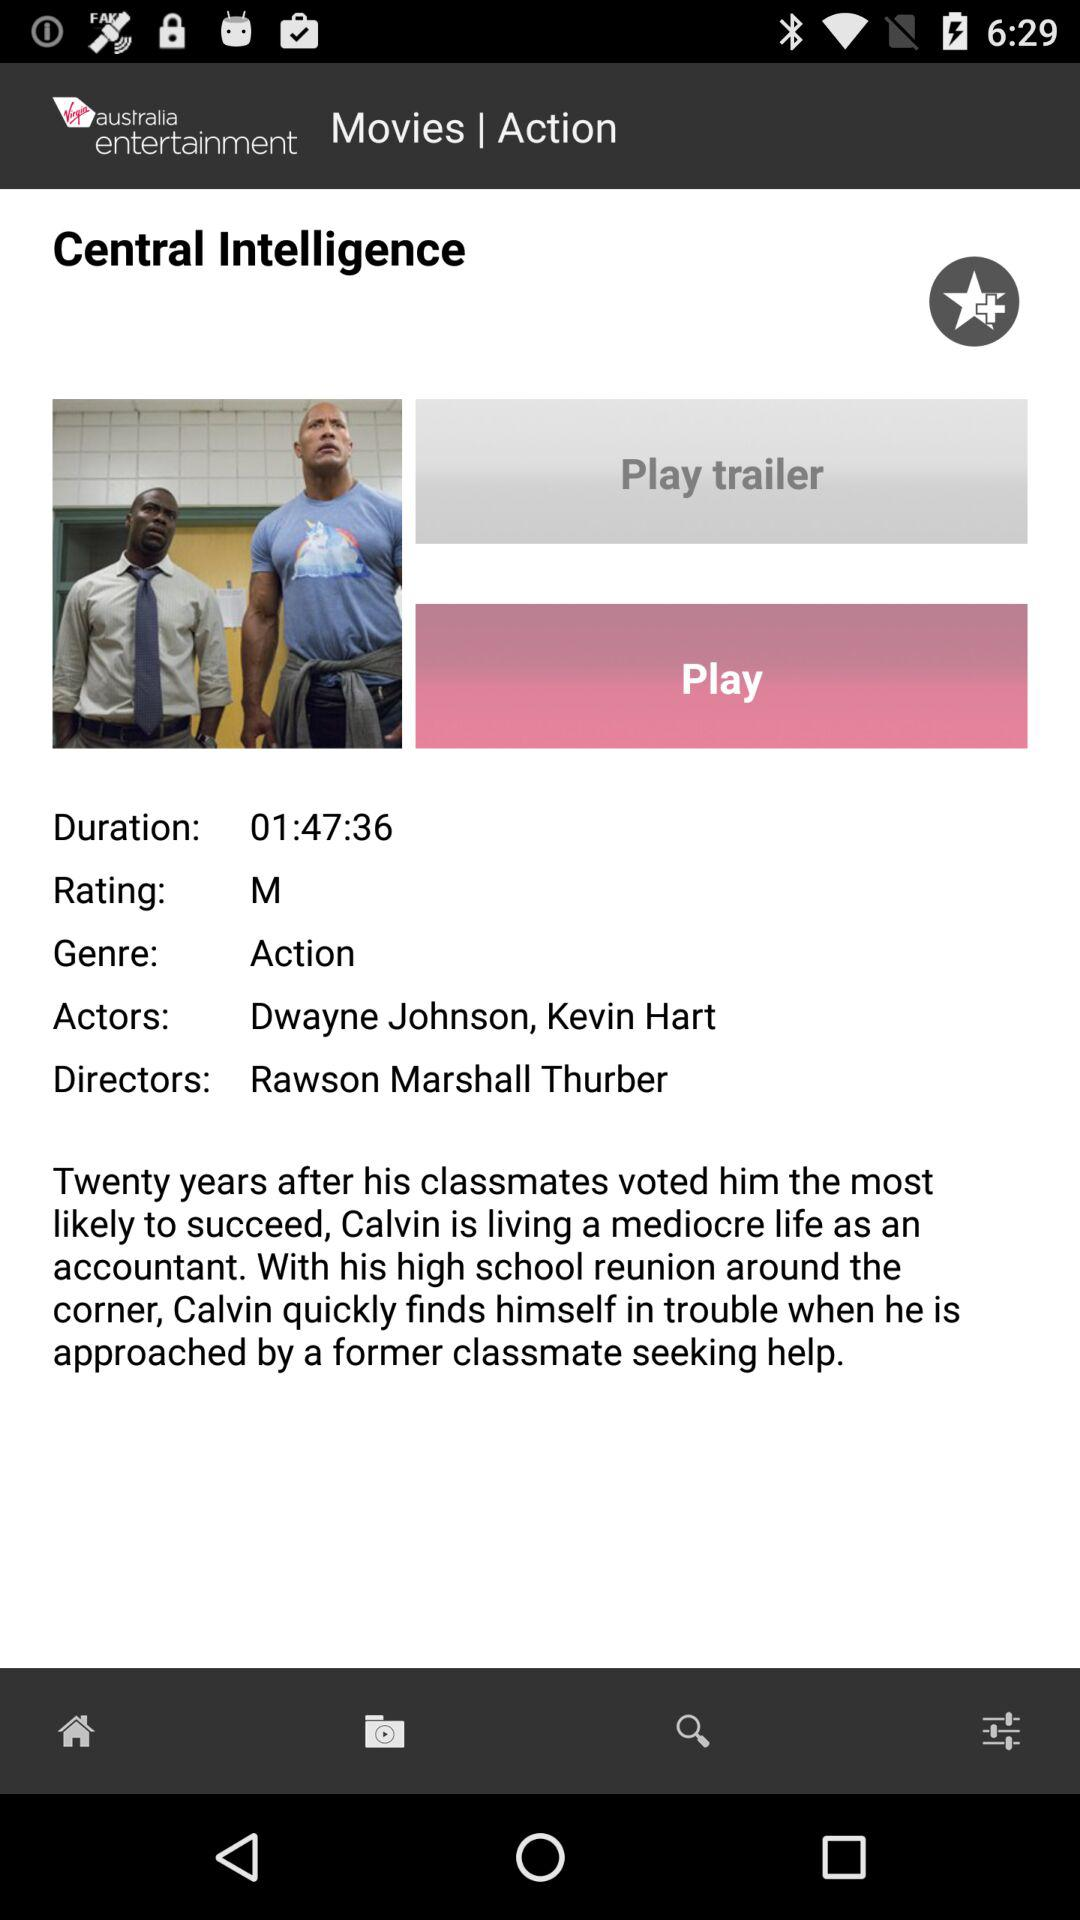Who are the actors in the movie? The actors in the movie are Dwayne Johnson and Kevin Hart. 